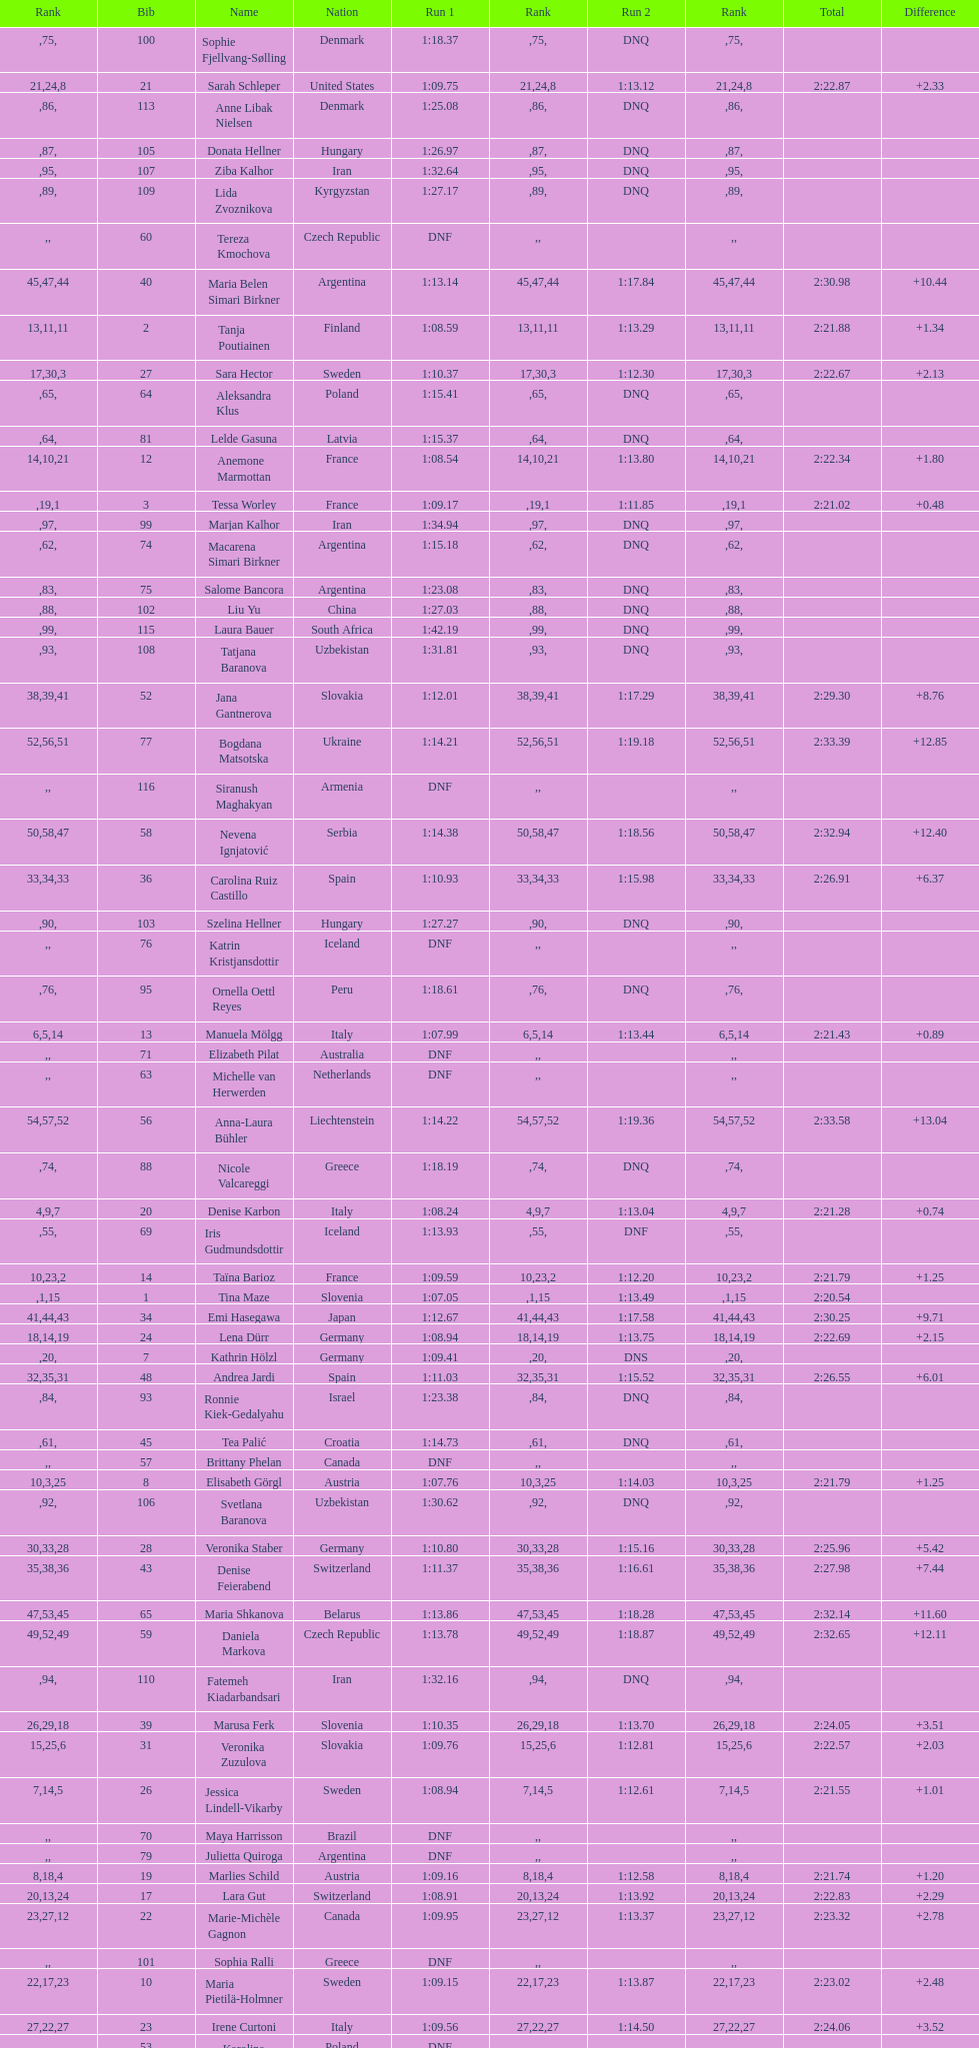Who was the last competitor to actually finish both runs? Martina Dubovska. 